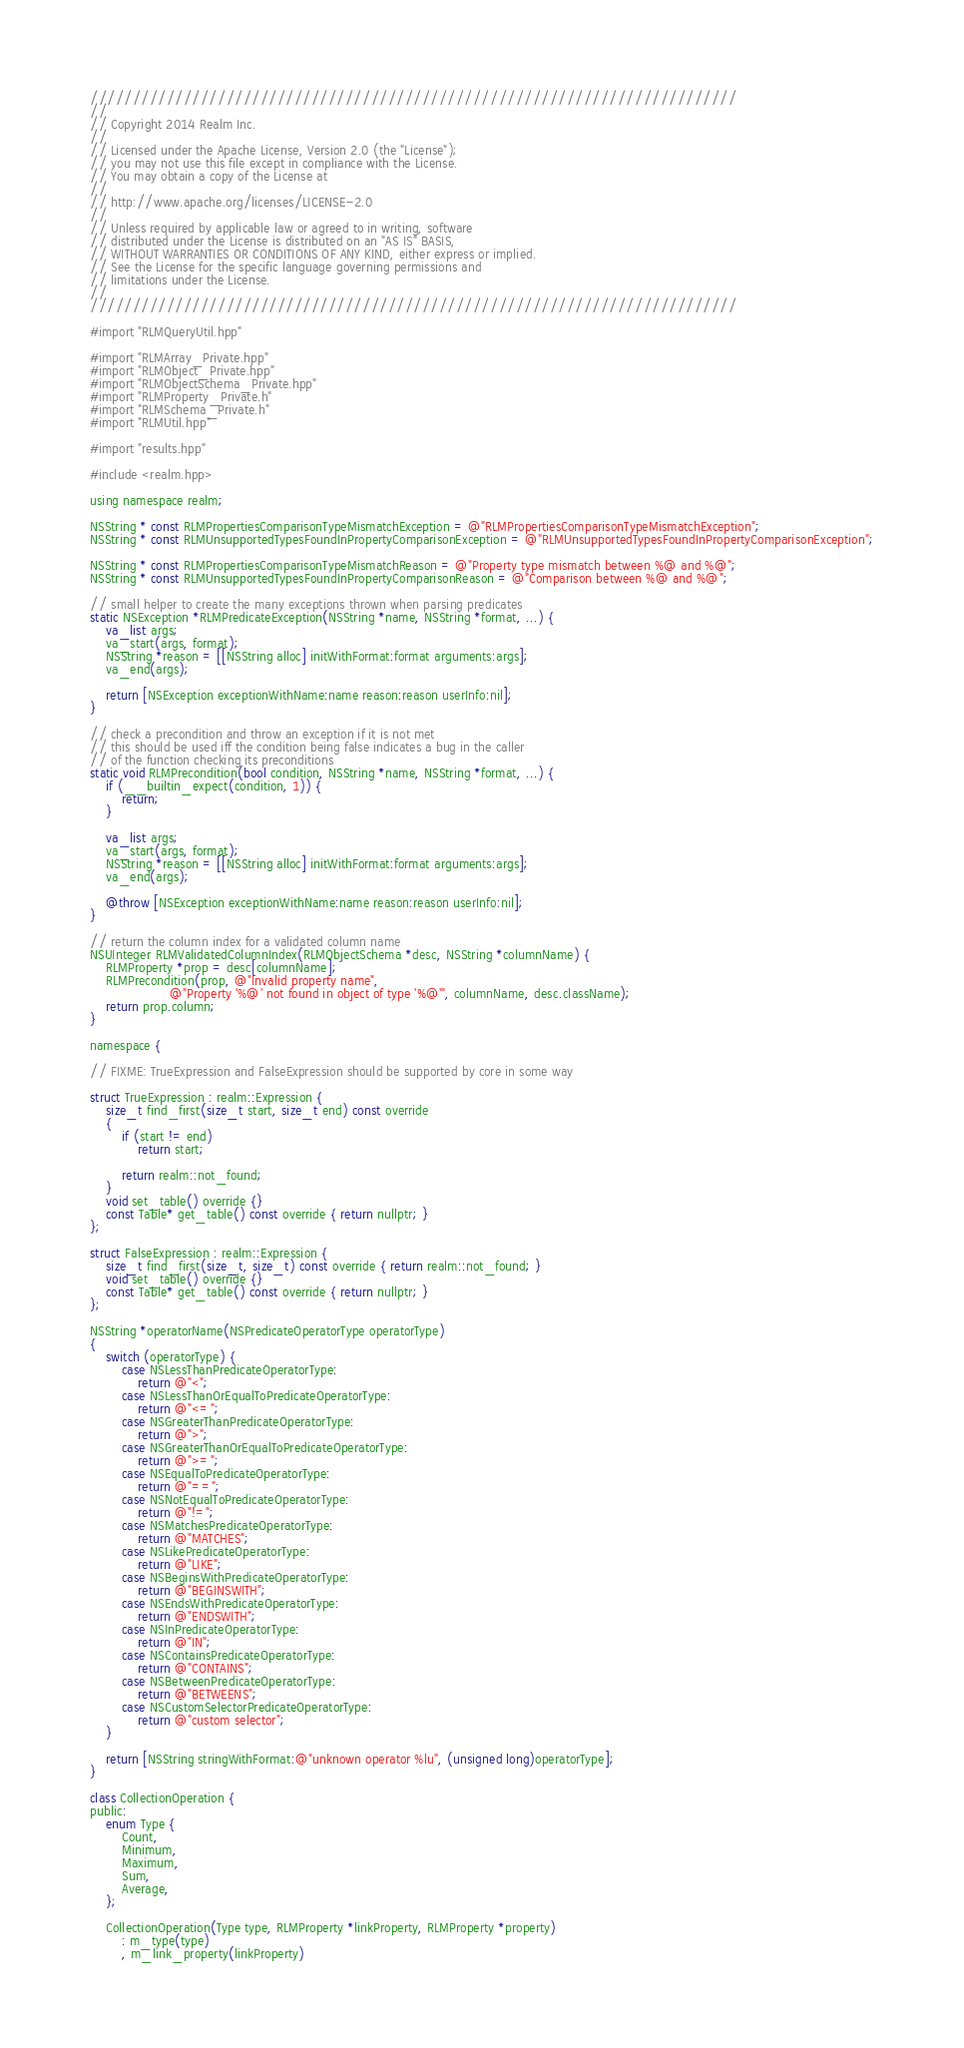Convert code to text. <code><loc_0><loc_0><loc_500><loc_500><_ObjectiveC_>////////////////////////////////////////////////////////////////////////////
//
// Copyright 2014 Realm Inc.
//
// Licensed under the Apache License, Version 2.0 (the "License");
// you may not use this file except in compliance with the License.
// You may obtain a copy of the License at
//
// http://www.apache.org/licenses/LICENSE-2.0
//
// Unless required by applicable law or agreed to in writing, software
// distributed under the License is distributed on an "AS IS" BASIS,
// WITHOUT WARRANTIES OR CONDITIONS OF ANY KIND, either express or implied.
// See the License for the specific language governing permissions and
// limitations under the License.
//
////////////////////////////////////////////////////////////////////////////

#import "RLMQueryUtil.hpp"

#import "RLMArray_Private.hpp"
#import "RLMObject_Private.hpp"
#import "RLMObjectSchema_Private.hpp"
#import "RLMProperty_Private.h"
#import "RLMSchema_Private.h"
#import "RLMUtil.hpp"

#import "results.hpp"

#include <realm.hpp>

using namespace realm;

NSString * const RLMPropertiesComparisonTypeMismatchException = @"RLMPropertiesComparisonTypeMismatchException";
NSString * const RLMUnsupportedTypesFoundInPropertyComparisonException = @"RLMUnsupportedTypesFoundInPropertyComparisonException";

NSString * const RLMPropertiesComparisonTypeMismatchReason = @"Property type mismatch between %@ and %@";
NSString * const RLMUnsupportedTypesFoundInPropertyComparisonReason = @"Comparison between %@ and %@";

// small helper to create the many exceptions thrown when parsing predicates
static NSException *RLMPredicateException(NSString *name, NSString *format, ...) {
    va_list args;
    va_start(args, format);
    NSString *reason = [[NSString alloc] initWithFormat:format arguments:args];
    va_end(args);

    return [NSException exceptionWithName:name reason:reason userInfo:nil];
}

// check a precondition and throw an exception if it is not met
// this should be used iff the condition being false indicates a bug in the caller
// of the function checking its preconditions
static void RLMPrecondition(bool condition, NSString *name, NSString *format, ...) {
    if (__builtin_expect(condition, 1)) {
        return;
    }

    va_list args;
    va_start(args, format);
    NSString *reason = [[NSString alloc] initWithFormat:format arguments:args];
    va_end(args);

    @throw [NSException exceptionWithName:name reason:reason userInfo:nil];
}

// return the column index for a validated column name
NSUInteger RLMValidatedColumnIndex(RLMObjectSchema *desc, NSString *columnName) {
    RLMProperty *prop = desc[columnName];
    RLMPrecondition(prop, @"Invalid property name",
                    @"Property '%@' not found in object of type '%@'", columnName, desc.className);
    return prop.column;
}

namespace {

// FIXME: TrueExpression and FalseExpression should be supported by core in some way

struct TrueExpression : realm::Expression {
    size_t find_first(size_t start, size_t end) const override
    {
        if (start != end)
            return start;

        return realm::not_found;
    }
    void set_table() override {}
    const Table* get_table() const override { return nullptr; }
};

struct FalseExpression : realm::Expression {
    size_t find_first(size_t, size_t) const override { return realm::not_found; }
    void set_table() override {}
    const Table* get_table() const override { return nullptr; }
};

NSString *operatorName(NSPredicateOperatorType operatorType)
{
    switch (operatorType) {
        case NSLessThanPredicateOperatorType:
            return @"<";
        case NSLessThanOrEqualToPredicateOperatorType:
            return @"<=";
        case NSGreaterThanPredicateOperatorType:
            return @">";
        case NSGreaterThanOrEqualToPredicateOperatorType:
            return @">=";
        case NSEqualToPredicateOperatorType:
            return @"==";
        case NSNotEqualToPredicateOperatorType:
            return @"!=";
        case NSMatchesPredicateOperatorType:
            return @"MATCHES";
        case NSLikePredicateOperatorType:
            return @"LIKE";
        case NSBeginsWithPredicateOperatorType:
            return @"BEGINSWITH";
        case NSEndsWithPredicateOperatorType:
            return @"ENDSWITH";
        case NSInPredicateOperatorType:
            return @"IN";
        case NSContainsPredicateOperatorType:
            return @"CONTAINS";
        case NSBetweenPredicateOperatorType:
            return @"BETWEENS";
        case NSCustomSelectorPredicateOperatorType:
            return @"custom selector";
    }

    return [NSString stringWithFormat:@"unknown operator %lu", (unsigned long)operatorType];
}

class CollectionOperation {
public:
    enum Type {
        Count,
        Minimum,
        Maximum,
        Sum,
        Average,
    };

    CollectionOperation(Type type, RLMProperty *linkProperty, RLMProperty *property)
        : m_type(type)
        , m_link_property(linkProperty)</code> 